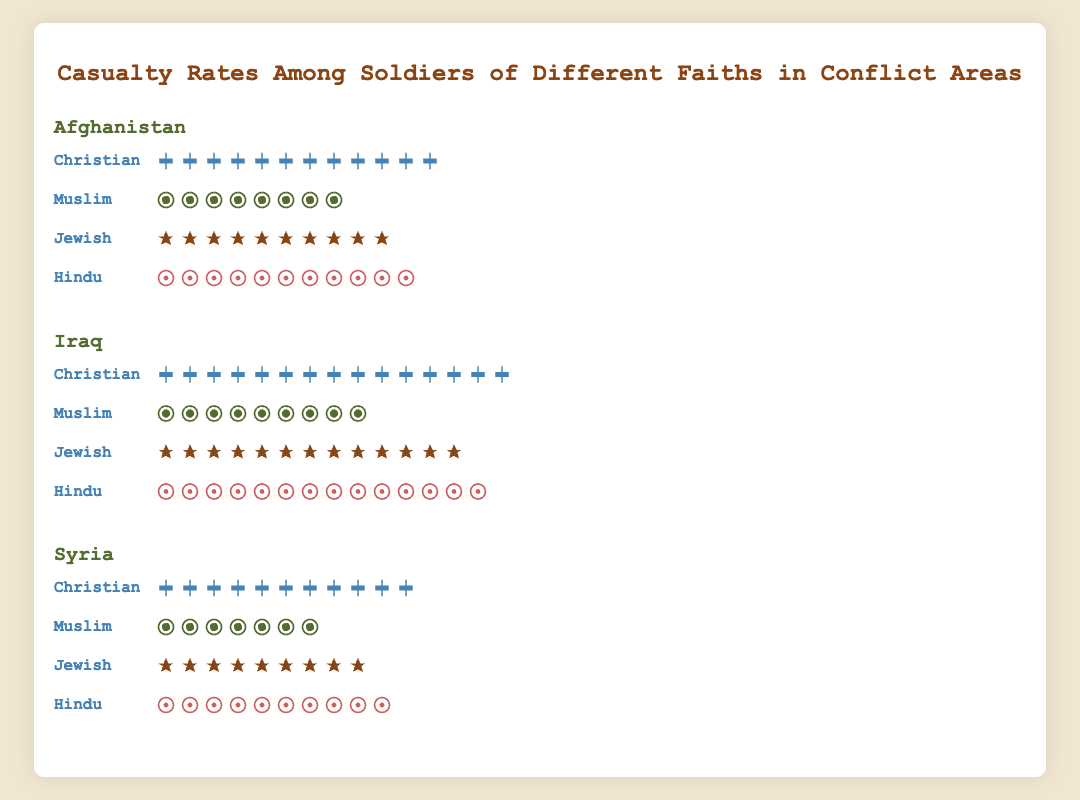What is the title of the figure? The title is prominent at the top of the figure in a larger font size: "Casualty Rates Among Soldiers of Different Faiths in Conflict Areas"
Answer: "Casualty Rates Among Soldiers of Different Faiths in Conflict Areas" What are the conflict areas highlighted in the figure? The conflict areas are listed as headers for each section in the figure: "Afghanistan", "Iraq", and "Syria"
Answer: "Afghanistan", "Iraq", "Syria" Which faith group has the highest casualty rate in Afghanistan? We need to compare the icon counts for each faith group in the Afghanistan section. "Christian" has 12 icons, which is the highest
Answer: "Christian" What is the difference in casualty rates between Christians and Muslims in Iraq? Look at the Iraq section: Christians have 15 icons, Muslims have 9 icons, and the difference is 15 - 9 = 6
Answer: 6 Which conflict area has the smallest casualty rate for Muslims? Compare the icon counts for Muslims across different conflict areas: Afghanistan (8 icons), Iraq (9 icons), and Syria (7 icons). Syria has the smallest count with 7 icons
Answer: "Syria" What is the total casualty rate for Hindus across all conflict areas? Add the icon counts for Hindus in all areas: Afghanistan (11), Iraq (14), and Syria (10), total is 11 + 14 + 10 = 35
Answer: 35 Which faith group has the lowest average casualty rate across the three conflict areas? Find the average rate for each faith by adding their icons across the areas and dividing by 3. Christians: (12+15+11)/3 = 12.67, Muslims: (8+9+7)/3 = 8, Jewish: (10+13+9)/3 = 10.67, Hindus: (11+14+10)/3 = 11.67. Muslims have the lowest average
Answer: "Muslim" How do the casualty rates for Jewish soldiers compare between Afghanistan and Syria? Check the icon counts for "Jewish" in Afghanistan (10) and Syria (9). Afghanistan has 1 more icon
Answer: Afghanistan has a 1-icon higher rate Based on the plot, which conflict area has the largest variation in casualty rates among different faiths? Afghanistan: 12 (Christian) - 8 (Muslim) = 4, Iraq: 15 (Christian) - 9 (Muslim) = 6, Syria: 11 (Christian) - 7 (Muslim) = 4. Iraq has the largest variation of 6
Answer: "Iraq" 